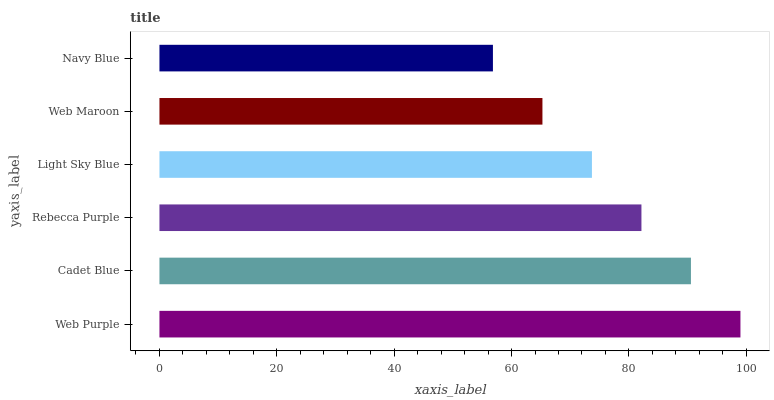Is Navy Blue the minimum?
Answer yes or no. Yes. Is Web Purple the maximum?
Answer yes or no. Yes. Is Cadet Blue the minimum?
Answer yes or no. No. Is Cadet Blue the maximum?
Answer yes or no. No. Is Web Purple greater than Cadet Blue?
Answer yes or no. Yes. Is Cadet Blue less than Web Purple?
Answer yes or no. Yes. Is Cadet Blue greater than Web Purple?
Answer yes or no. No. Is Web Purple less than Cadet Blue?
Answer yes or no. No. Is Rebecca Purple the high median?
Answer yes or no. Yes. Is Light Sky Blue the low median?
Answer yes or no. Yes. Is Navy Blue the high median?
Answer yes or no. No. Is Web Maroon the low median?
Answer yes or no. No. 